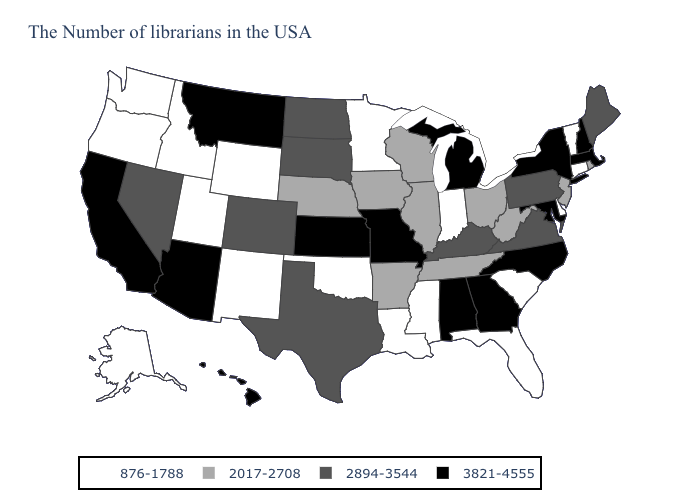What is the value of North Dakota?
Keep it brief. 2894-3544. What is the value of Minnesota?
Be succinct. 876-1788. What is the value of California?
Give a very brief answer. 3821-4555. What is the value of Texas?
Give a very brief answer. 2894-3544. What is the highest value in states that border Washington?
Answer briefly. 876-1788. Name the states that have a value in the range 3821-4555?
Answer briefly. Massachusetts, New Hampshire, New York, Maryland, North Carolina, Georgia, Michigan, Alabama, Missouri, Kansas, Montana, Arizona, California, Hawaii. What is the highest value in the USA?
Keep it brief. 3821-4555. Name the states that have a value in the range 876-1788?
Concise answer only. Vermont, Connecticut, Delaware, South Carolina, Florida, Indiana, Mississippi, Louisiana, Minnesota, Oklahoma, Wyoming, New Mexico, Utah, Idaho, Washington, Oregon, Alaska. What is the value of South Carolina?
Write a very short answer. 876-1788. Name the states that have a value in the range 2017-2708?
Write a very short answer. Rhode Island, New Jersey, West Virginia, Ohio, Tennessee, Wisconsin, Illinois, Arkansas, Iowa, Nebraska. What is the value of Idaho?
Concise answer only. 876-1788. Name the states that have a value in the range 876-1788?
Concise answer only. Vermont, Connecticut, Delaware, South Carolina, Florida, Indiana, Mississippi, Louisiana, Minnesota, Oklahoma, Wyoming, New Mexico, Utah, Idaho, Washington, Oregon, Alaska. Does Rhode Island have a lower value than Washington?
Concise answer only. No. Name the states that have a value in the range 2017-2708?
Short answer required. Rhode Island, New Jersey, West Virginia, Ohio, Tennessee, Wisconsin, Illinois, Arkansas, Iowa, Nebraska. What is the highest value in states that border Wisconsin?
Be succinct. 3821-4555. 